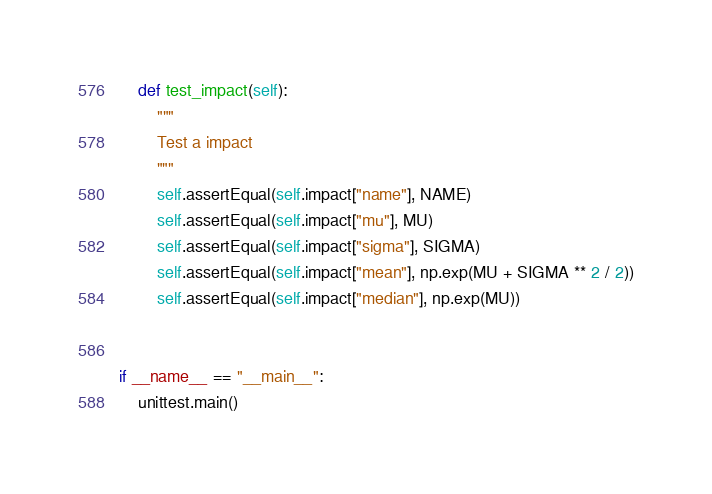<code> <loc_0><loc_0><loc_500><loc_500><_Python_>
    def test_impact(self):
        """
        Test a impact
        """
        self.assertEqual(self.impact["name"], NAME)
        self.assertEqual(self.impact["mu"], MU)
        self.assertEqual(self.impact["sigma"], SIGMA)
        self.assertEqual(self.impact["mean"], np.exp(MU + SIGMA ** 2 / 2))
        self.assertEqual(self.impact["median"], np.exp(MU))


if __name__ == "__main__":
    unittest.main()
</code> 